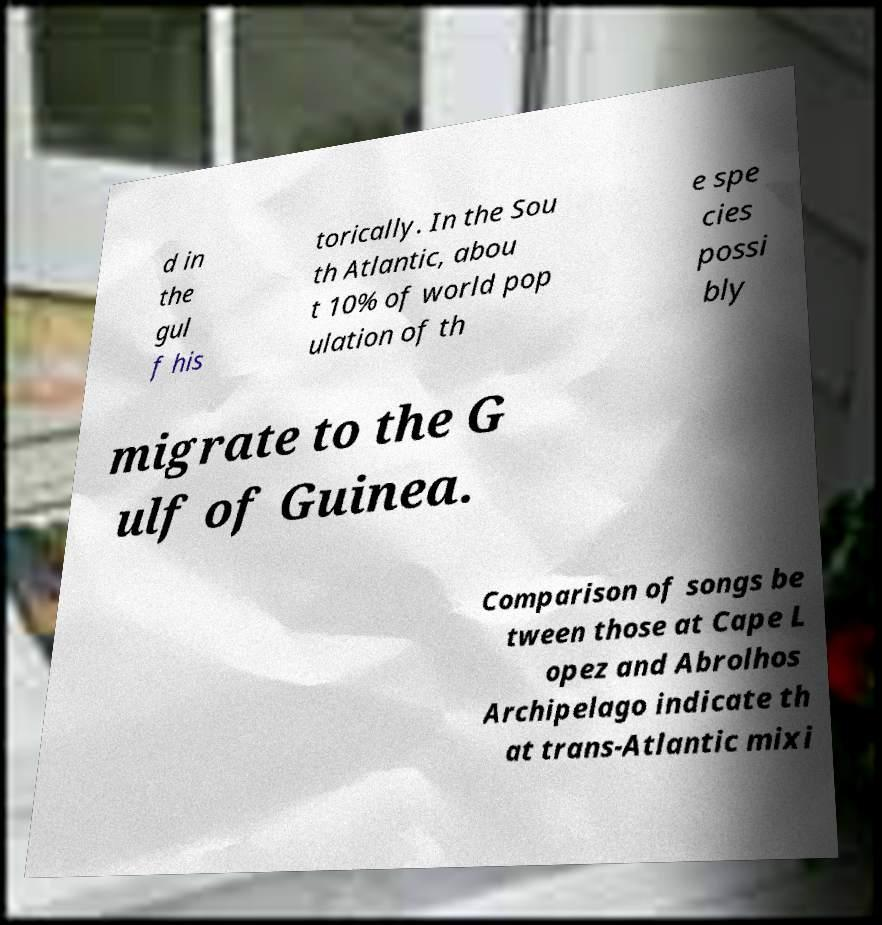There's text embedded in this image that I need extracted. Can you transcribe it verbatim? d in the gul f his torically. In the Sou th Atlantic, abou t 10% of world pop ulation of th e spe cies possi bly migrate to the G ulf of Guinea. Comparison of songs be tween those at Cape L opez and Abrolhos Archipelago indicate th at trans-Atlantic mixi 